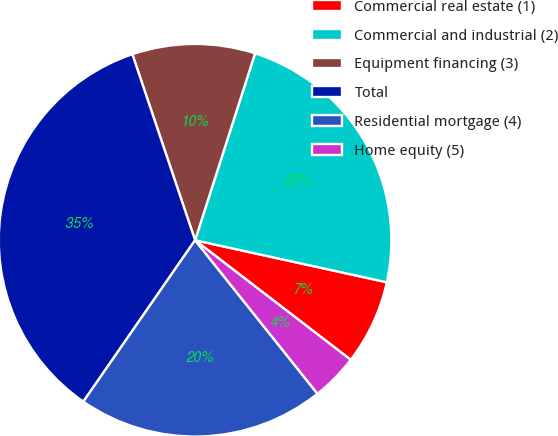<chart> <loc_0><loc_0><loc_500><loc_500><pie_chart><fcel>Commercial real estate (1)<fcel>Commercial and industrial (2)<fcel>Equipment financing (3)<fcel>Total<fcel>Residential mortgage (4)<fcel>Home equity (5)<nl><fcel>6.99%<fcel>23.49%<fcel>10.12%<fcel>35.18%<fcel>20.35%<fcel>3.86%<nl></chart> 